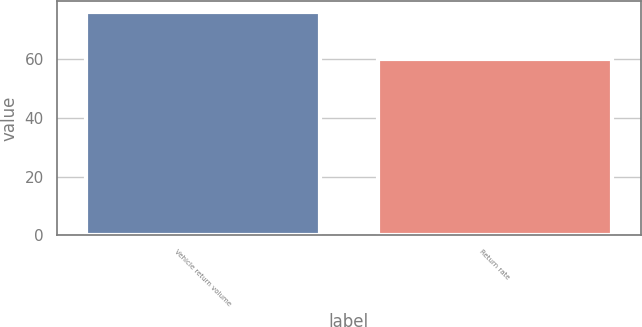<chart> <loc_0><loc_0><loc_500><loc_500><bar_chart><fcel>Vehicle return volume<fcel>Return rate<nl><fcel>76<fcel>60<nl></chart> 